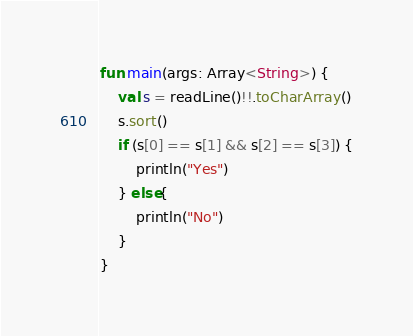Convert code to text. <code><loc_0><loc_0><loc_500><loc_500><_Kotlin_>fun main(args: Array<String>) {
    val s = readLine()!!.toCharArray()
    s.sort()
    if (s[0] == s[1] && s[2] == s[3]) {
        println("Yes")
    } else{
        println("No")
    }
}
</code> 